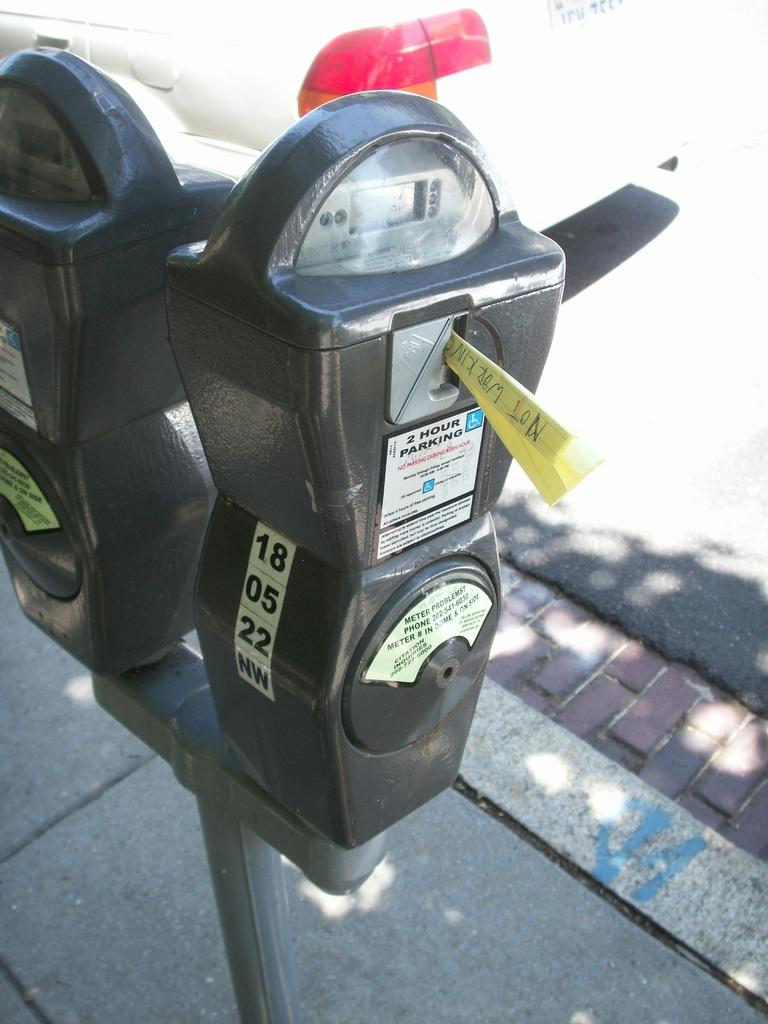<image>
Summarize the visual content of the image. A parking meter has the numbers 18, 05 and 22 on the side of the meter. 